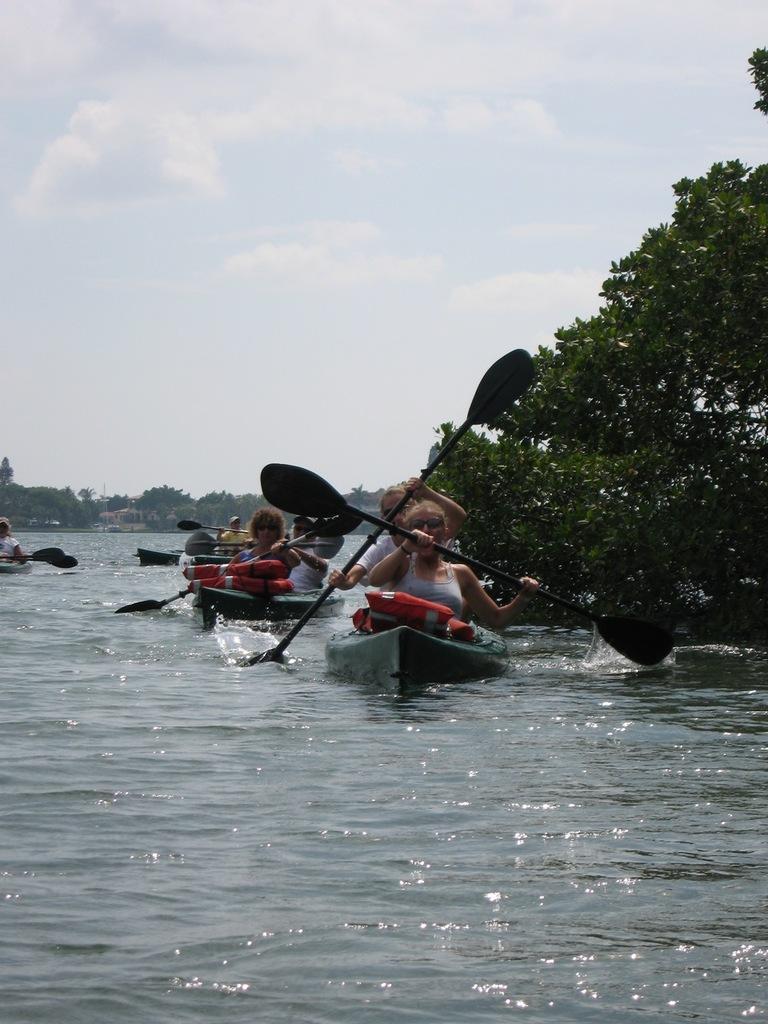Can you describe this image briefly? In this image I see few persons boating on the water. In the background I see trees and the sky. 